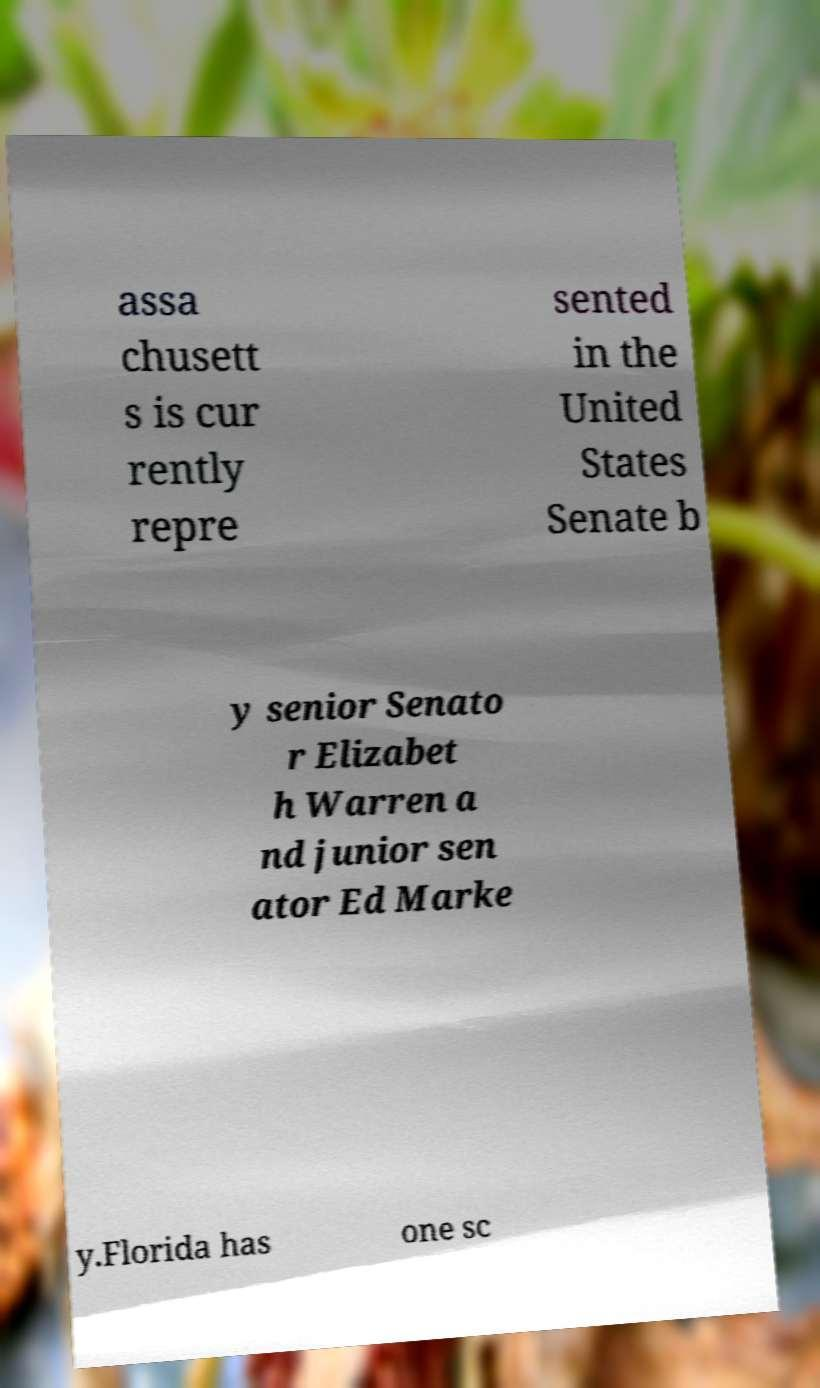Could you extract and type out the text from this image? assa chusett s is cur rently repre sented in the United States Senate b y senior Senato r Elizabet h Warren a nd junior sen ator Ed Marke y.Florida has one sc 